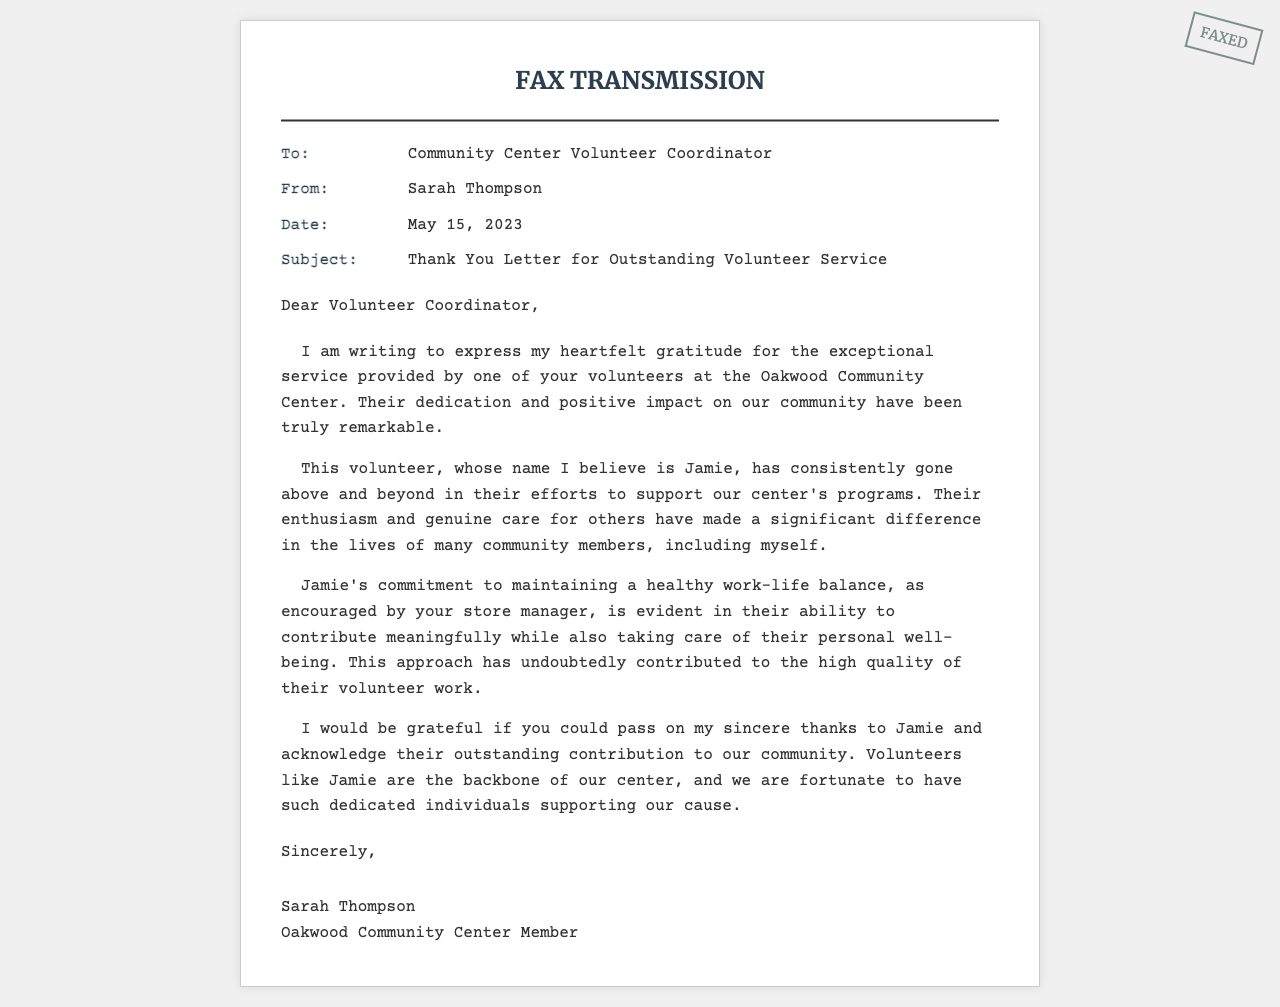What is the date of the fax? The date of the fax is provided in the header section.
Answer: May 15, 2023 Who is the sender of the letter? The sender's name is mentioned in the 'From' section of the document.
Answer: Sarah Thompson What is the subject of the fax? The subject is stated in the 'Subject' section, indicating the purpose of the fax.
Answer: Thank You Letter for Outstanding Volunteer Service What is the name of the volunteer mentioned in the letter? The volunteer's name is stated in the body of the letter as the individual being praised.
Answer: Jamie What contribution does Jamie make to the community? The letter describes Jamie's efforts and positive impact on the community center's programs.
Answer: Support for the center's programs How does the letter describe the relationship between Jamie and work-life balance? The letter highlights Jamie's commitment to work-life balance encouraged by the store manager.
Answer: Maintains a healthy work-life balance What type of letter is this document? The overall structure and content suggest its classification in correspondence types.
Answer: Thank-you letter What is the recipient role mentioned in the document? The recipient role is defined in the 'To' section, indicating to whom the letter is directed.
Answer: Volunteer Coordinator Why does Sarah Thompson express gratitude in the letter? The main intention of the letter is to communicate appreciation for Jamie's service.
Answer: Exceptional service and dedication 